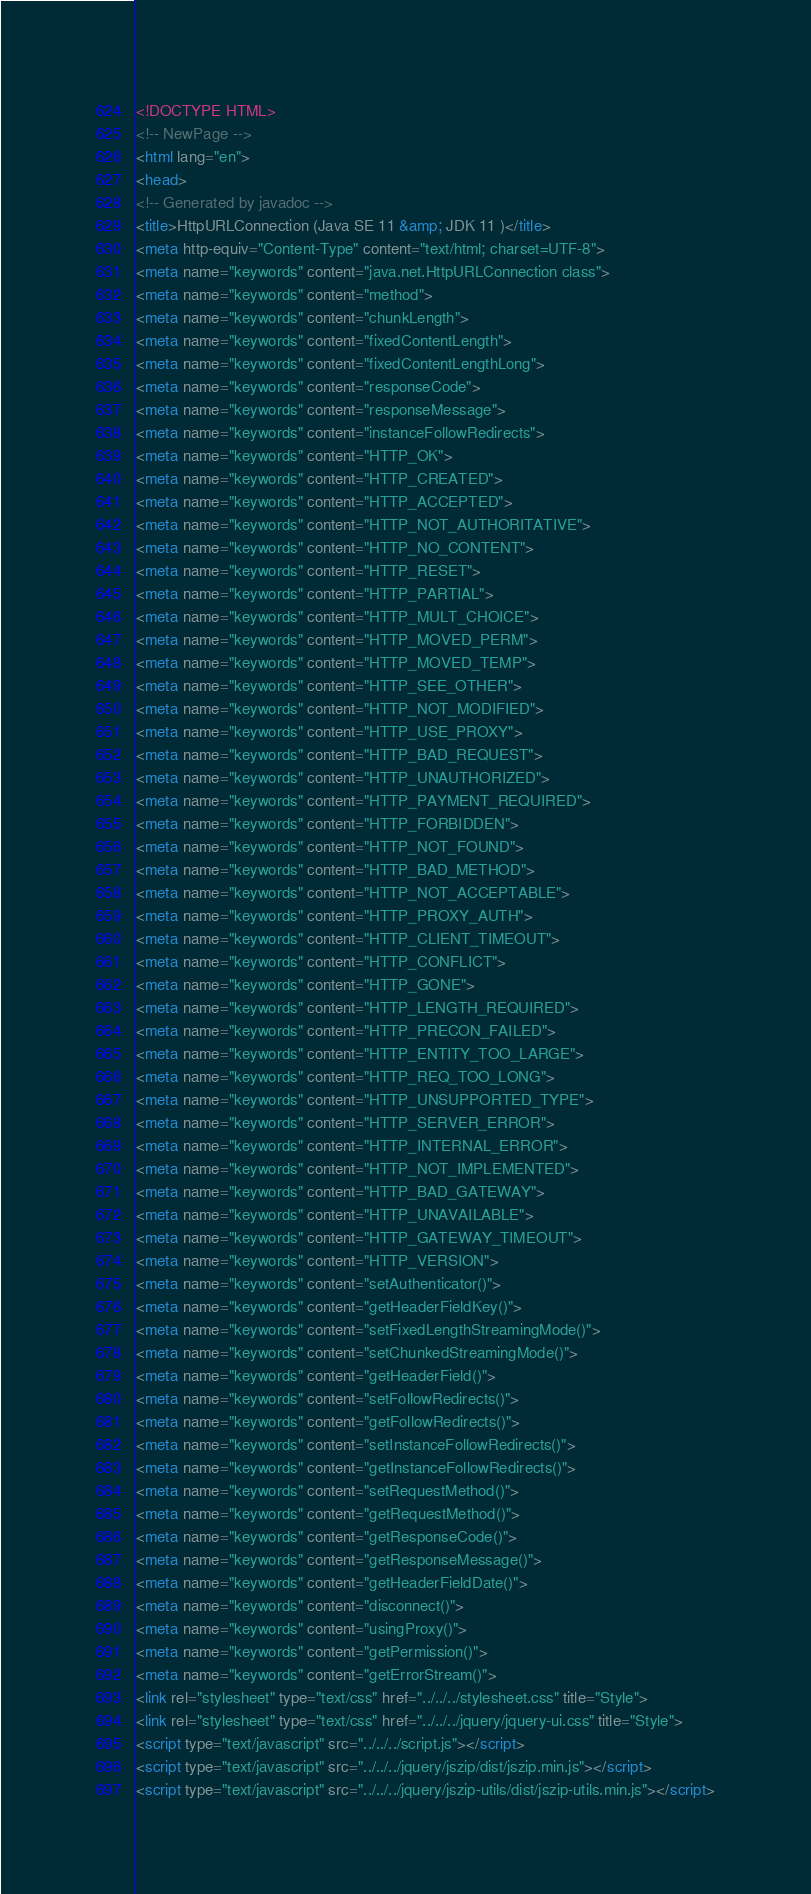<code> <loc_0><loc_0><loc_500><loc_500><_HTML_><!DOCTYPE HTML>
<!-- NewPage -->
<html lang="en">
<head>
<!-- Generated by javadoc -->
<title>HttpURLConnection (Java SE 11 &amp; JDK 11 )</title>
<meta http-equiv="Content-Type" content="text/html; charset=UTF-8">
<meta name="keywords" content="java.net.HttpURLConnection class">
<meta name="keywords" content="method">
<meta name="keywords" content="chunkLength">
<meta name="keywords" content="fixedContentLength">
<meta name="keywords" content="fixedContentLengthLong">
<meta name="keywords" content="responseCode">
<meta name="keywords" content="responseMessage">
<meta name="keywords" content="instanceFollowRedirects">
<meta name="keywords" content="HTTP_OK">
<meta name="keywords" content="HTTP_CREATED">
<meta name="keywords" content="HTTP_ACCEPTED">
<meta name="keywords" content="HTTP_NOT_AUTHORITATIVE">
<meta name="keywords" content="HTTP_NO_CONTENT">
<meta name="keywords" content="HTTP_RESET">
<meta name="keywords" content="HTTP_PARTIAL">
<meta name="keywords" content="HTTP_MULT_CHOICE">
<meta name="keywords" content="HTTP_MOVED_PERM">
<meta name="keywords" content="HTTP_MOVED_TEMP">
<meta name="keywords" content="HTTP_SEE_OTHER">
<meta name="keywords" content="HTTP_NOT_MODIFIED">
<meta name="keywords" content="HTTP_USE_PROXY">
<meta name="keywords" content="HTTP_BAD_REQUEST">
<meta name="keywords" content="HTTP_UNAUTHORIZED">
<meta name="keywords" content="HTTP_PAYMENT_REQUIRED">
<meta name="keywords" content="HTTP_FORBIDDEN">
<meta name="keywords" content="HTTP_NOT_FOUND">
<meta name="keywords" content="HTTP_BAD_METHOD">
<meta name="keywords" content="HTTP_NOT_ACCEPTABLE">
<meta name="keywords" content="HTTP_PROXY_AUTH">
<meta name="keywords" content="HTTP_CLIENT_TIMEOUT">
<meta name="keywords" content="HTTP_CONFLICT">
<meta name="keywords" content="HTTP_GONE">
<meta name="keywords" content="HTTP_LENGTH_REQUIRED">
<meta name="keywords" content="HTTP_PRECON_FAILED">
<meta name="keywords" content="HTTP_ENTITY_TOO_LARGE">
<meta name="keywords" content="HTTP_REQ_TOO_LONG">
<meta name="keywords" content="HTTP_UNSUPPORTED_TYPE">
<meta name="keywords" content="HTTP_SERVER_ERROR">
<meta name="keywords" content="HTTP_INTERNAL_ERROR">
<meta name="keywords" content="HTTP_NOT_IMPLEMENTED">
<meta name="keywords" content="HTTP_BAD_GATEWAY">
<meta name="keywords" content="HTTP_UNAVAILABLE">
<meta name="keywords" content="HTTP_GATEWAY_TIMEOUT">
<meta name="keywords" content="HTTP_VERSION">
<meta name="keywords" content="setAuthenticator()">
<meta name="keywords" content="getHeaderFieldKey()">
<meta name="keywords" content="setFixedLengthStreamingMode()">
<meta name="keywords" content="setChunkedStreamingMode()">
<meta name="keywords" content="getHeaderField()">
<meta name="keywords" content="setFollowRedirects()">
<meta name="keywords" content="getFollowRedirects()">
<meta name="keywords" content="setInstanceFollowRedirects()">
<meta name="keywords" content="getInstanceFollowRedirects()">
<meta name="keywords" content="setRequestMethod()">
<meta name="keywords" content="getRequestMethod()">
<meta name="keywords" content="getResponseCode()">
<meta name="keywords" content="getResponseMessage()">
<meta name="keywords" content="getHeaderFieldDate()">
<meta name="keywords" content="disconnect()">
<meta name="keywords" content="usingProxy()">
<meta name="keywords" content="getPermission()">
<meta name="keywords" content="getErrorStream()">
<link rel="stylesheet" type="text/css" href="../../../stylesheet.css" title="Style">
<link rel="stylesheet" type="text/css" href="../../../jquery/jquery-ui.css" title="Style">
<script type="text/javascript" src="../../../script.js"></script>
<script type="text/javascript" src="../../../jquery/jszip/dist/jszip.min.js"></script>
<script type="text/javascript" src="../../../jquery/jszip-utils/dist/jszip-utils.min.js"></script></code> 